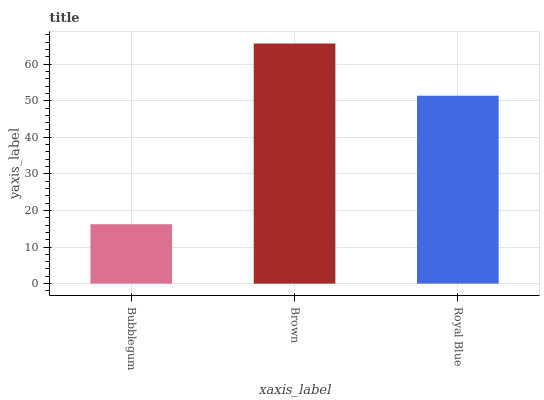Is Royal Blue the minimum?
Answer yes or no. No. Is Royal Blue the maximum?
Answer yes or no. No. Is Brown greater than Royal Blue?
Answer yes or no. Yes. Is Royal Blue less than Brown?
Answer yes or no. Yes. Is Royal Blue greater than Brown?
Answer yes or no. No. Is Brown less than Royal Blue?
Answer yes or no. No. Is Royal Blue the high median?
Answer yes or no. Yes. Is Royal Blue the low median?
Answer yes or no. Yes. Is Bubblegum the high median?
Answer yes or no. No. Is Brown the low median?
Answer yes or no. No. 